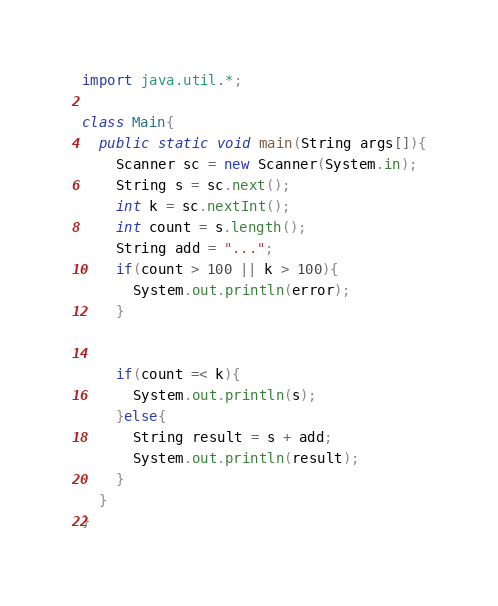<code> <loc_0><loc_0><loc_500><loc_500><_Java_>import java.util.*;
 
class Main{
  public static void main(String args[]){
    Scanner sc = new Scanner(System.in);
    String s = sc.next();
    int k = sc.nextInt();
    int count = s.length();
    String add = "...";
    if(count > 100 || k > 100){
      System.out.println(error);
    }
    
    
    if(count =< k){
      System.out.println(s);
    }else{
      String result = s + add;
      System.out.println(result);
    }
  }
}</code> 